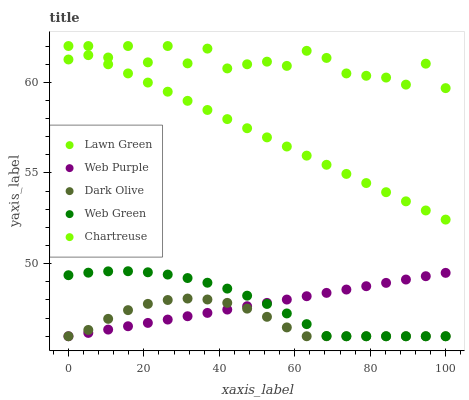Does Dark Olive have the minimum area under the curve?
Answer yes or no. Yes. Does Lawn Green have the maximum area under the curve?
Answer yes or no. Yes. Does Web Purple have the minimum area under the curve?
Answer yes or no. No. Does Web Purple have the maximum area under the curve?
Answer yes or no. No. Is Chartreuse the smoothest?
Answer yes or no. Yes. Is Lawn Green the roughest?
Answer yes or no. Yes. Is Web Purple the smoothest?
Answer yes or no. No. Is Web Purple the roughest?
Answer yes or no. No. Does Web Purple have the lowest value?
Answer yes or no. Yes. Does Chartreuse have the lowest value?
Answer yes or no. No. Does Chartreuse have the highest value?
Answer yes or no. Yes. Does Web Purple have the highest value?
Answer yes or no. No. Is Web Green less than Chartreuse?
Answer yes or no. Yes. Is Chartreuse greater than Web Purple?
Answer yes or no. Yes. Does Web Green intersect Dark Olive?
Answer yes or no. Yes. Is Web Green less than Dark Olive?
Answer yes or no. No. Is Web Green greater than Dark Olive?
Answer yes or no. No. Does Web Green intersect Chartreuse?
Answer yes or no. No. 